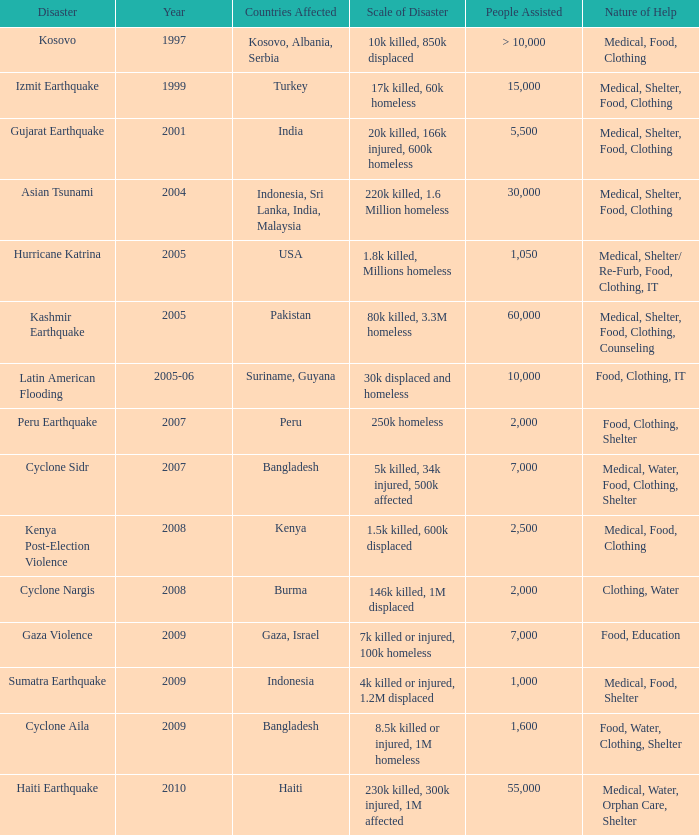What was the number of individuals helped in 1997? > 10,000. 